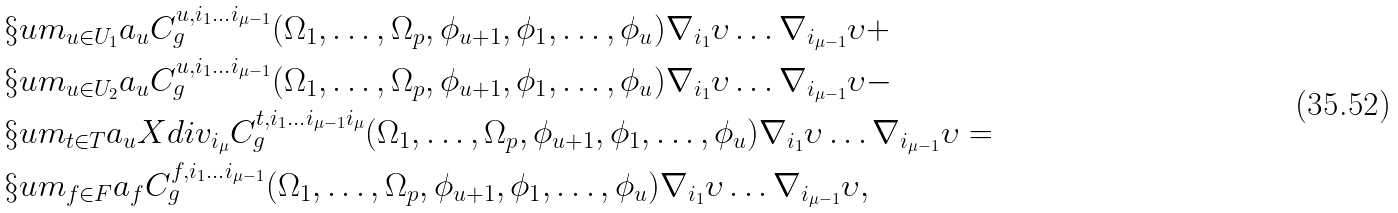Convert formula to latex. <formula><loc_0><loc_0><loc_500><loc_500>& \S u m _ { u \in U _ { 1 } } a _ { u } C ^ { u , i _ { 1 } \dots i _ { \mu - 1 } } _ { g } ( \Omega _ { 1 } , \dots , \Omega _ { p } , \phi _ { u + 1 } , \phi _ { 1 } , \dots , \phi _ { u } ) \nabla _ { i _ { 1 } } \upsilon \dots \nabla _ { i _ { \mu - 1 } } \upsilon + \\ & \S u m _ { u \in U _ { 2 } } a _ { u } C ^ { u , i _ { 1 } \dots i _ { \mu - 1 } } _ { g } ( \Omega _ { 1 } , \dots , \Omega _ { p } , \phi _ { u + 1 } , \phi _ { 1 } , \dots , \phi _ { u } ) \nabla _ { i _ { 1 } } \upsilon \dots \nabla _ { i _ { \mu - 1 } } \upsilon - \\ & \S u m _ { t \in T } a _ { u } X d i v _ { i _ { \mu } } C ^ { t , i _ { 1 } \dots i _ { \mu - 1 } i _ { \mu } } _ { g } ( \Omega _ { 1 } , \dots , \Omega _ { p } , \phi _ { u + 1 } , \phi _ { 1 } , \dots , \phi _ { u } ) \nabla _ { i _ { 1 } } \upsilon \dots \nabla _ { i _ { \mu - 1 } } \upsilon = \\ & \S u m _ { f \in F } a _ { f } C ^ { f , i _ { 1 } \dots i _ { \mu - 1 } } _ { g } ( \Omega _ { 1 } , \dots , \Omega _ { p } , \phi _ { u + 1 } , \phi _ { 1 } , \dots , \phi _ { u } ) \nabla _ { i _ { 1 } } \upsilon \dots \nabla _ { i _ { \mu - 1 } } \upsilon ,</formula> 